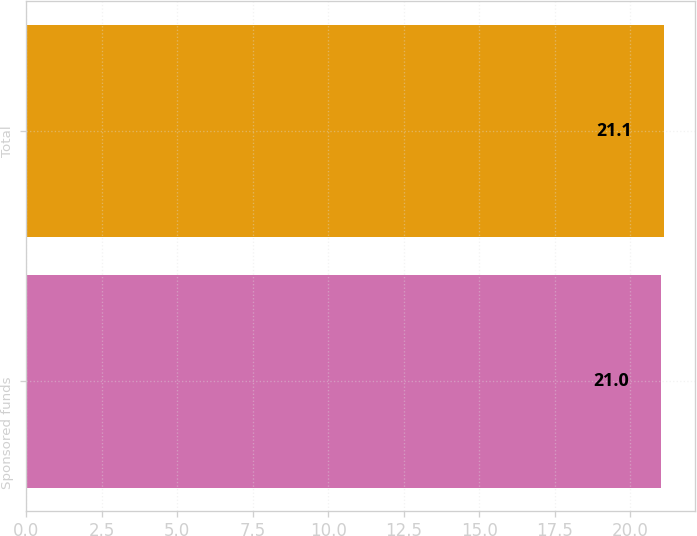Convert chart. <chart><loc_0><loc_0><loc_500><loc_500><bar_chart><fcel>Sponsored funds<fcel>Total<nl><fcel>21<fcel>21.1<nl></chart> 